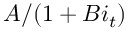<formula> <loc_0><loc_0><loc_500><loc_500>A / ( 1 + B i _ { t } )</formula> 